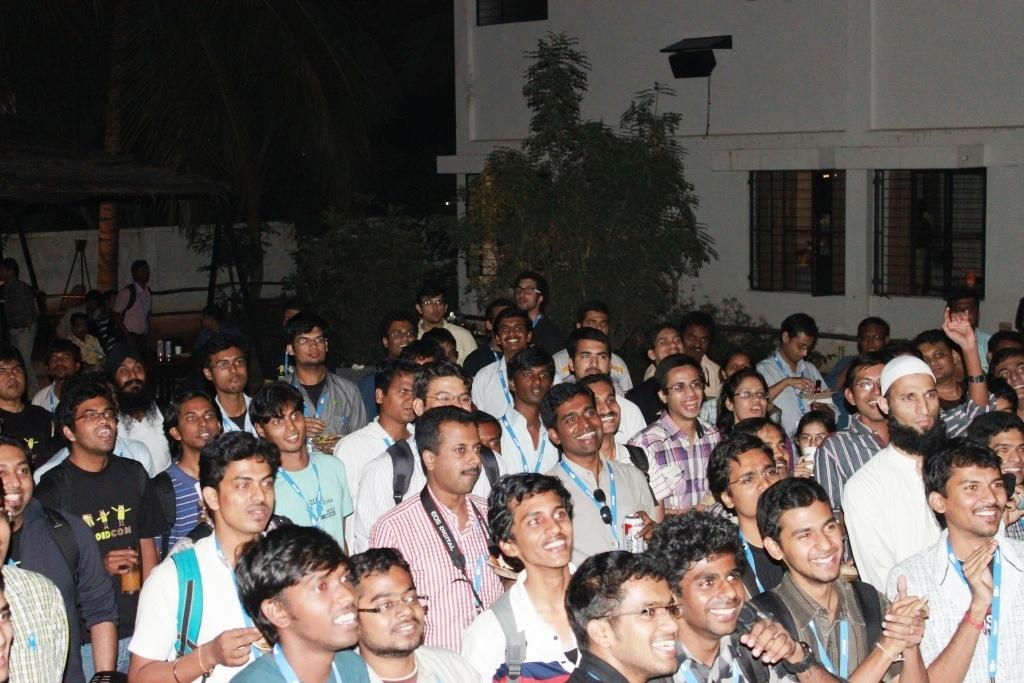What are the people in the image doing? The people in the image are sitting. What is the facial expression of the people in the image? The people are smiling. What can be seen in the background of the image? There are trees visible in the background of the image. What is located on the right side of the image? There is a building on the right side of the image. Can you see any ants crawling on the people in the image? There are no ants visible in the image; the focus is on the people sitting and smiling. 